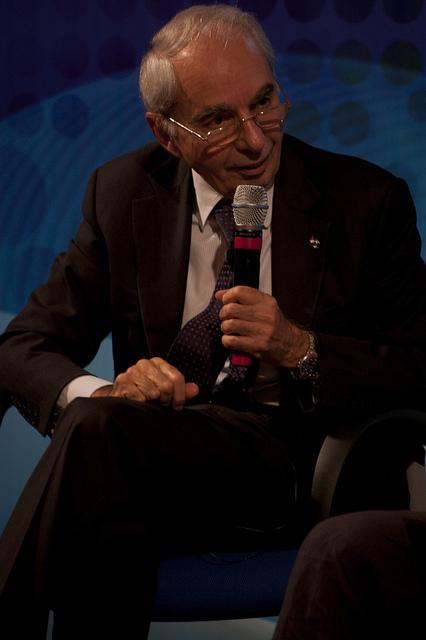How might many who listen to this speaker hear his message? Please explain your reasoning. through speakers. You can hear him through the speakers. 